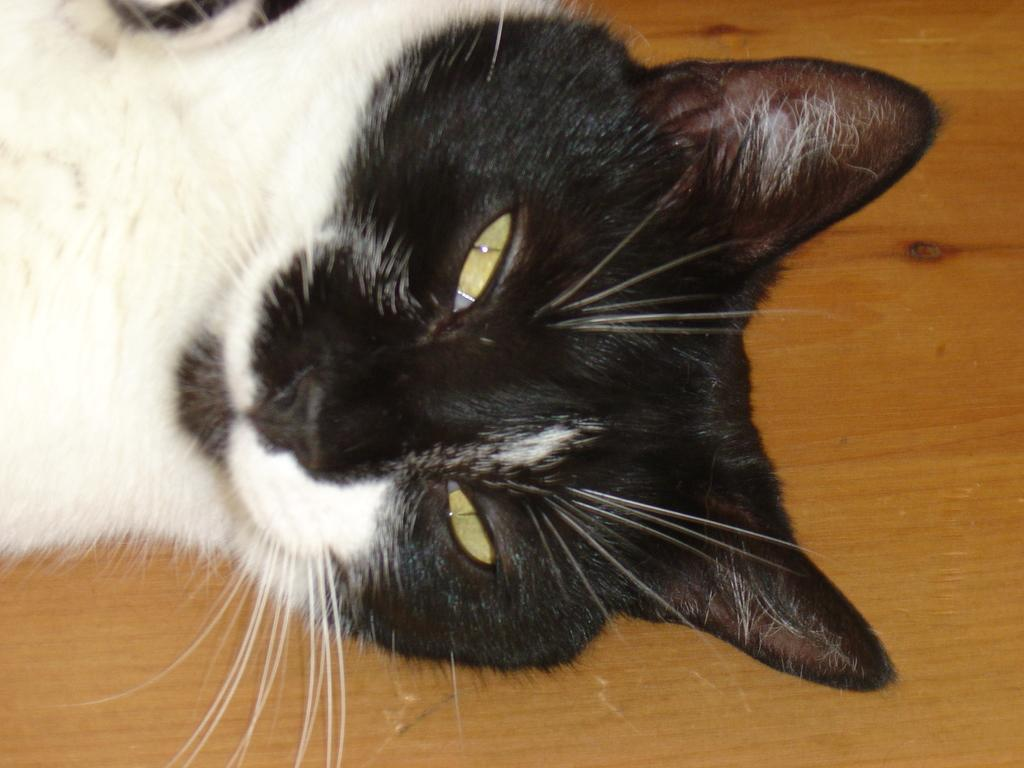What type of animal is in the image? There is a cat in the image. Where is the cat located in the image? The cat is on the floor. What colors are the cat's fur? The cat is black and white in color. What type of scene is the cat nesting in the image? There is no scene or nest present in the image; it simply features a cat on the floor. How many dimes can be seen near the cat in the image? There are no dimes present in the image. 